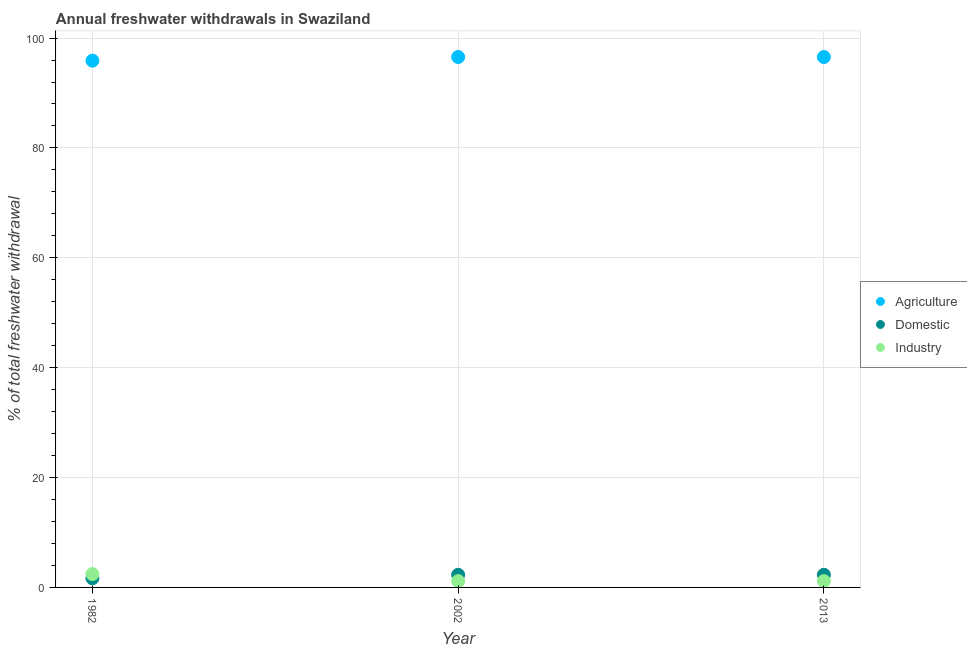Is the number of dotlines equal to the number of legend labels?
Make the answer very short. Yes. What is the percentage of freshwater withdrawal for agriculture in 2013?
Give a very brief answer. 96.55. Across all years, what is the maximum percentage of freshwater withdrawal for domestic purposes?
Give a very brief answer. 2.3. Across all years, what is the minimum percentage of freshwater withdrawal for domestic purposes?
Keep it short and to the point. 1.67. In which year was the percentage of freshwater withdrawal for agriculture maximum?
Offer a terse response. 2002. In which year was the percentage of freshwater withdrawal for domestic purposes minimum?
Your response must be concise. 1982. What is the total percentage of freshwater withdrawal for industry in the graph?
Ensure brevity in your answer.  4.74. What is the difference between the percentage of freshwater withdrawal for domestic purposes in 1982 and that in 2013?
Your answer should be very brief. -0.63. What is the difference between the percentage of freshwater withdrawal for agriculture in 2013 and the percentage of freshwater withdrawal for industry in 2002?
Provide a short and direct response. 95.4. What is the average percentage of freshwater withdrawal for agriculture per year?
Make the answer very short. 96.33. In the year 2002, what is the difference between the percentage of freshwater withdrawal for industry and percentage of freshwater withdrawal for agriculture?
Make the answer very short. -95.4. In how many years, is the percentage of freshwater withdrawal for agriculture greater than 84 %?
Your answer should be very brief. 3. What is the difference between the highest and the lowest percentage of freshwater withdrawal for agriculture?
Your answer should be compact. 0.66. In how many years, is the percentage of freshwater withdrawal for industry greater than the average percentage of freshwater withdrawal for industry taken over all years?
Offer a very short reply. 1. Does the percentage of freshwater withdrawal for agriculture monotonically increase over the years?
Ensure brevity in your answer.  No. Is the percentage of freshwater withdrawal for agriculture strictly less than the percentage of freshwater withdrawal for industry over the years?
Offer a terse response. No. How many years are there in the graph?
Give a very brief answer. 3. What is the difference between two consecutive major ticks on the Y-axis?
Give a very brief answer. 20. Does the graph contain any zero values?
Ensure brevity in your answer.  No. Does the graph contain grids?
Provide a short and direct response. Yes. Where does the legend appear in the graph?
Your answer should be compact. Center right. How are the legend labels stacked?
Make the answer very short. Vertical. What is the title of the graph?
Keep it short and to the point. Annual freshwater withdrawals in Swaziland. Does "Female employers" appear as one of the legend labels in the graph?
Your answer should be very brief. No. What is the label or title of the Y-axis?
Your answer should be compact. % of total freshwater withdrawal. What is the % of total freshwater withdrawal of Agriculture in 1982?
Your answer should be compact. 95.89. What is the % of total freshwater withdrawal in Domestic in 1982?
Your answer should be compact. 1.67. What is the % of total freshwater withdrawal in Industry in 1982?
Offer a very short reply. 2.44. What is the % of total freshwater withdrawal in Agriculture in 2002?
Your answer should be compact. 96.55. What is the % of total freshwater withdrawal in Domestic in 2002?
Make the answer very short. 2.3. What is the % of total freshwater withdrawal in Industry in 2002?
Make the answer very short. 1.15. What is the % of total freshwater withdrawal in Agriculture in 2013?
Keep it short and to the point. 96.55. What is the % of total freshwater withdrawal of Domestic in 2013?
Ensure brevity in your answer.  2.3. What is the % of total freshwater withdrawal in Industry in 2013?
Your response must be concise. 1.15. Across all years, what is the maximum % of total freshwater withdrawal of Agriculture?
Offer a terse response. 96.55. Across all years, what is the maximum % of total freshwater withdrawal of Domestic?
Give a very brief answer. 2.3. Across all years, what is the maximum % of total freshwater withdrawal of Industry?
Ensure brevity in your answer.  2.44. Across all years, what is the minimum % of total freshwater withdrawal of Agriculture?
Provide a short and direct response. 95.89. Across all years, what is the minimum % of total freshwater withdrawal in Domestic?
Your response must be concise. 1.67. Across all years, what is the minimum % of total freshwater withdrawal in Industry?
Keep it short and to the point. 1.15. What is the total % of total freshwater withdrawal of Agriculture in the graph?
Offer a terse response. 288.99. What is the total % of total freshwater withdrawal of Domestic in the graph?
Provide a succinct answer. 6.28. What is the total % of total freshwater withdrawal in Industry in the graph?
Make the answer very short. 4.74. What is the difference between the % of total freshwater withdrawal of Agriculture in 1982 and that in 2002?
Offer a very short reply. -0.66. What is the difference between the % of total freshwater withdrawal of Domestic in 1982 and that in 2002?
Keep it short and to the point. -0.63. What is the difference between the % of total freshwater withdrawal in Industry in 1982 and that in 2002?
Your answer should be compact. 1.28. What is the difference between the % of total freshwater withdrawal in Agriculture in 1982 and that in 2013?
Offer a terse response. -0.66. What is the difference between the % of total freshwater withdrawal of Domestic in 1982 and that in 2013?
Give a very brief answer. -0.63. What is the difference between the % of total freshwater withdrawal of Industry in 1982 and that in 2013?
Provide a short and direct response. 1.28. What is the difference between the % of total freshwater withdrawal in Agriculture in 2002 and that in 2013?
Make the answer very short. 0. What is the difference between the % of total freshwater withdrawal of Industry in 2002 and that in 2013?
Your answer should be compact. 0. What is the difference between the % of total freshwater withdrawal of Agriculture in 1982 and the % of total freshwater withdrawal of Domestic in 2002?
Ensure brevity in your answer.  93.59. What is the difference between the % of total freshwater withdrawal of Agriculture in 1982 and the % of total freshwater withdrawal of Industry in 2002?
Ensure brevity in your answer.  94.74. What is the difference between the % of total freshwater withdrawal in Domestic in 1982 and the % of total freshwater withdrawal in Industry in 2002?
Ensure brevity in your answer.  0.52. What is the difference between the % of total freshwater withdrawal in Agriculture in 1982 and the % of total freshwater withdrawal in Domestic in 2013?
Offer a very short reply. 93.59. What is the difference between the % of total freshwater withdrawal of Agriculture in 1982 and the % of total freshwater withdrawal of Industry in 2013?
Offer a terse response. 94.74. What is the difference between the % of total freshwater withdrawal of Domestic in 1982 and the % of total freshwater withdrawal of Industry in 2013?
Provide a short and direct response. 0.52. What is the difference between the % of total freshwater withdrawal of Agriculture in 2002 and the % of total freshwater withdrawal of Domestic in 2013?
Give a very brief answer. 94.25. What is the difference between the % of total freshwater withdrawal of Agriculture in 2002 and the % of total freshwater withdrawal of Industry in 2013?
Keep it short and to the point. 95.4. What is the difference between the % of total freshwater withdrawal of Domestic in 2002 and the % of total freshwater withdrawal of Industry in 2013?
Offer a very short reply. 1.15. What is the average % of total freshwater withdrawal of Agriculture per year?
Your response must be concise. 96.33. What is the average % of total freshwater withdrawal in Domestic per year?
Your response must be concise. 2.09. What is the average % of total freshwater withdrawal of Industry per year?
Provide a short and direct response. 1.58. In the year 1982, what is the difference between the % of total freshwater withdrawal of Agriculture and % of total freshwater withdrawal of Domestic?
Your answer should be compact. 94.22. In the year 1982, what is the difference between the % of total freshwater withdrawal of Agriculture and % of total freshwater withdrawal of Industry?
Provide a succinct answer. 93.45. In the year 1982, what is the difference between the % of total freshwater withdrawal of Domestic and % of total freshwater withdrawal of Industry?
Give a very brief answer. -0.76. In the year 2002, what is the difference between the % of total freshwater withdrawal of Agriculture and % of total freshwater withdrawal of Domestic?
Your answer should be compact. 94.25. In the year 2002, what is the difference between the % of total freshwater withdrawal of Agriculture and % of total freshwater withdrawal of Industry?
Your answer should be compact. 95.4. In the year 2002, what is the difference between the % of total freshwater withdrawal of Domestic and % of total freshwater withdrawal of Industry?
Provide a short and direct response. 1.15. In the year 2013, what is the difference between the % of total freshwater withdrawal of Agriculture and % of total freshwater withdrawal of Domestic?
Give a very brief answer. 94.25. In the year 2013, what is the difference between the % of total freshwater withdrawal in Agriculture and % of total freshwater withdrawal in Industry?
Offer a very short reply. 95.4. In the year 2013, what is the difference between the % of total freshwater withdrawal in Domestic and % of total freshwater withdrawal in Industry?
Ensure brevity in your answer.  1.15. What is the ratio of the % of total freshwater withdrawal of Domestic in 1982 to that in 2002?
Offer a terse response. 0.73. What is the ratio of the % of total freshwater withdrawal of Industry in 1982 to that in 2002?
Your answer should be very brief. 2.11. What is the ratio of the % of total freshwater withdrawal of Agriculture in 1982 to that in 2013?
Keep it short and to the point. 0.99. What is the ratio of the % of total freshwater withdrawal of Domestic in 1982 to that in 2013?
Provide a short and direct response. 0.73. What is the ratio of the % of total freshwater withdrawal of Industry in 1982 to that in 2013?
Your response must be concise. 2.11. What is the ratio of the % of total freshwater withdrawal in Domestic in 2002 to that in 2013?
Your answer should be compact. 1. What is the difference between the highest and the second highest % of total freshwater withdrawal in Agriculture?
Provide a short and direct response. 0. What is the difference between the highest and the second highest % of total freshwater withdrawal of Domestic?
Offer a terse response. 0. What is the difference between the highest and the second highest % of total freshwater withdrawal in Industry?
Keep it short and to the point. 1.28. What is the difference between the highest and the lowest % of total freshwater withdrawal in Agriculture?
Your answer should be very brief. 0.66. What is the difference between the highest and the lowest % of total freshwater withdrawal in Domestic?
Your answer should be compact. 0.63. What is the difference between the highest and the lowest % of total freshwater withdrawal in Industry?
Your answer should be compact. 1.28. 